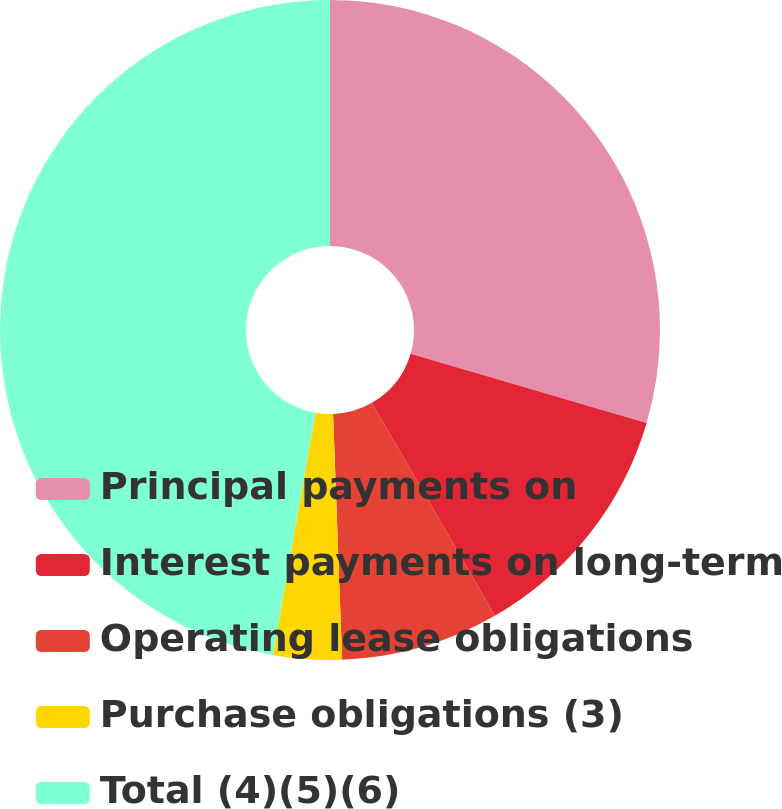Convert chart to OTSL. <chart><loc_0><loc_0><loc_500><loc_500><pie_chart><fcel>Principal payments on<fcel>Interest payments on long-term<fcel>Operating lease obligations<fcel>Purchase obligations (3)<fcel>Total (4)(5)(6)<nl><fcel>29.54%<fcel>12.13%<fcel>7.74%<fcel>3.35%<fcel>47.23%<nl></chart> 